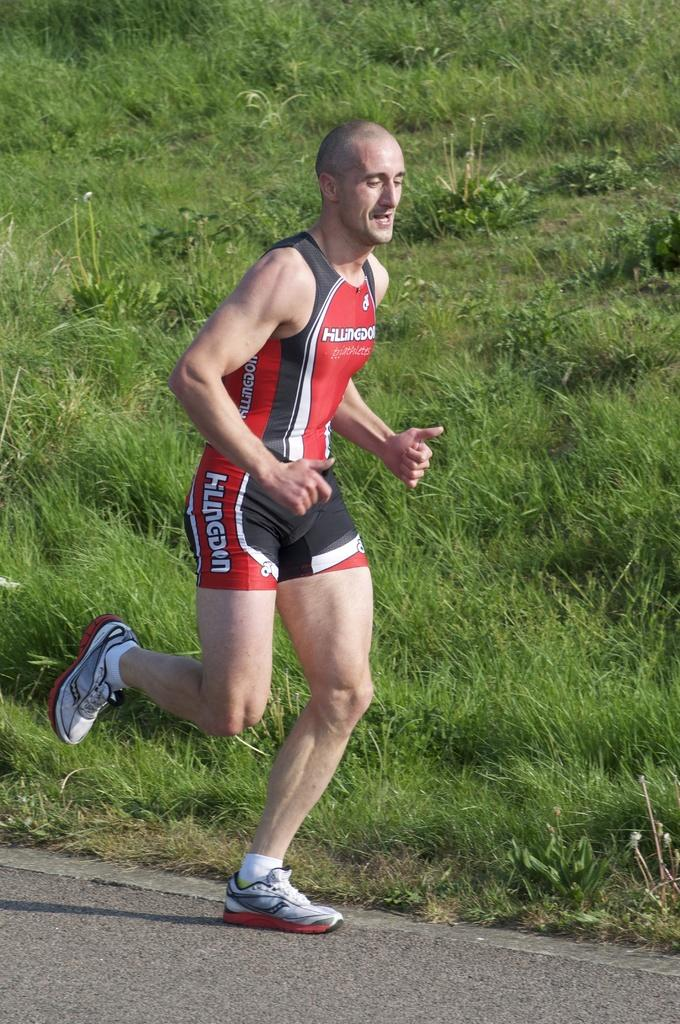What is the main subject of the image? The main subject of the image is a man. What is the man doing in the image? The man is running in the image. What can be seen in the background of the image? There are plants and grass in the background of the image. What type of substance is the man using to enhance his running speed in the image? There is no indication in the image that the man is using any substance to enhance his running speed. 